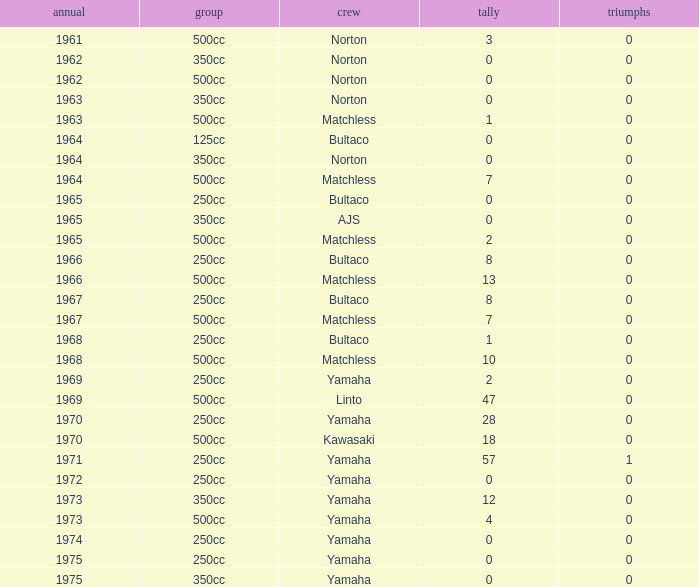Which class corresponds to more than 2 points, wins greater than 0, and a year earlier than 1973? 250cc. 